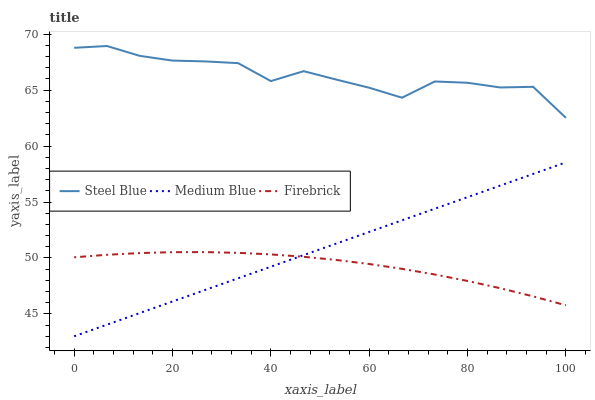Does Firebrick have the minimum area under the curve?
Answer yes or no. Yes. Does Steel Blue have the maximum area under the curve?
Answer yes or no. Yes. Does Medium Blue have the minimum area under the curve?
Answer yes or no. No. Does Medium Blue have the maximum area under the curve?
Answer yes or no. No. Is Medium Blue the smoothest?
Answer yes or no. Yes. Is Steel Blue the roughest?
Answer yes or no. Yes. Is Steel Blue the smoothest?
Answer yes or no. No. Is Medium Blue the roughest?
Answer yes or no. No. Does Medium Blue have the lowest value?
Answer yes or no. Yes. Does Steel Blue have the lowest value?
Answer yes or no. No. Does Steel Blue have the highest value?
Answer yes or no. Yes. Does Medium Blue have the highest value?
Answer yes or no. No. Is Medium Blue less than Steel Blue?
Answer yes or no. Yes. Is Steel Blue greater than Firebrick?
Answer yes or no. Yes. Does Firebrick intersect Medium Blue?
Answer yes or no. Yes. Is Firebrick less than Medium Blue?
Answer yes or no. No. Is Firebrick greater than Medium Blue?
Answer yes or no. No. Does Medium Blue intersect Steel Blue?
Answer yes or no. No. 